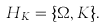<formula> <loc_0><loc_0><loc_500><loc_500>H _ { K } = \{ \Omega , K \} .</formula> 